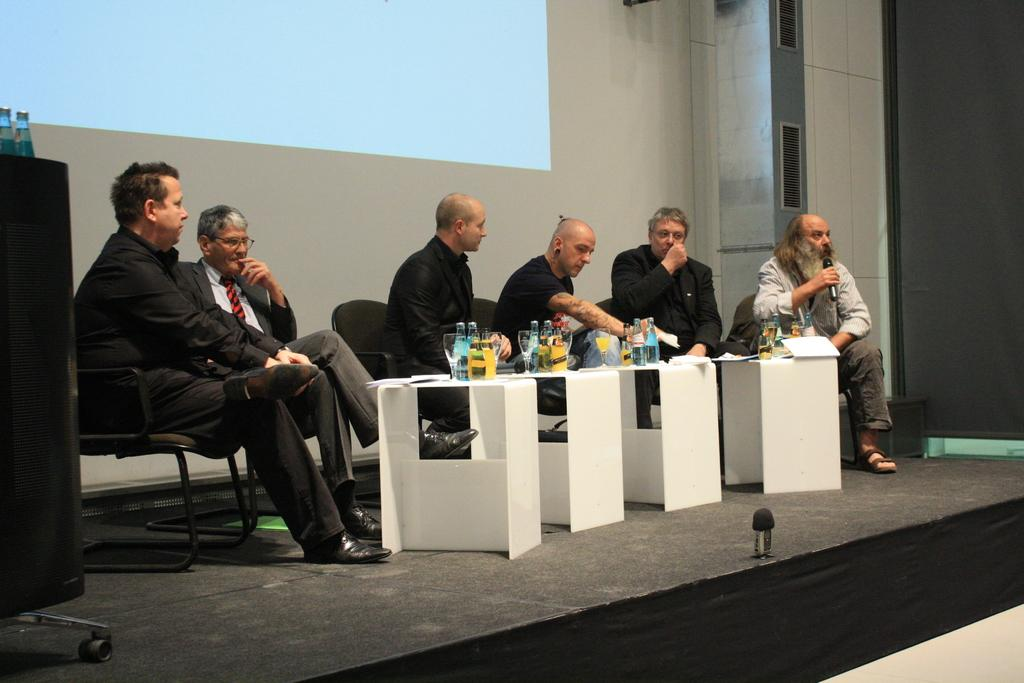What are the people in the image doing? The people in the image are sitting on chairs. What objects are in front of the people? The people have bottles in front of them. What can be seen in the background of the image? There is an LCD projector visible in the background of the image. What type of sugar is being used to solve the riddle in the image? There is no sugar or riddle present in the image; it only shows people sitting on chairs with bottles in front of them and an LCD projector in the background. 